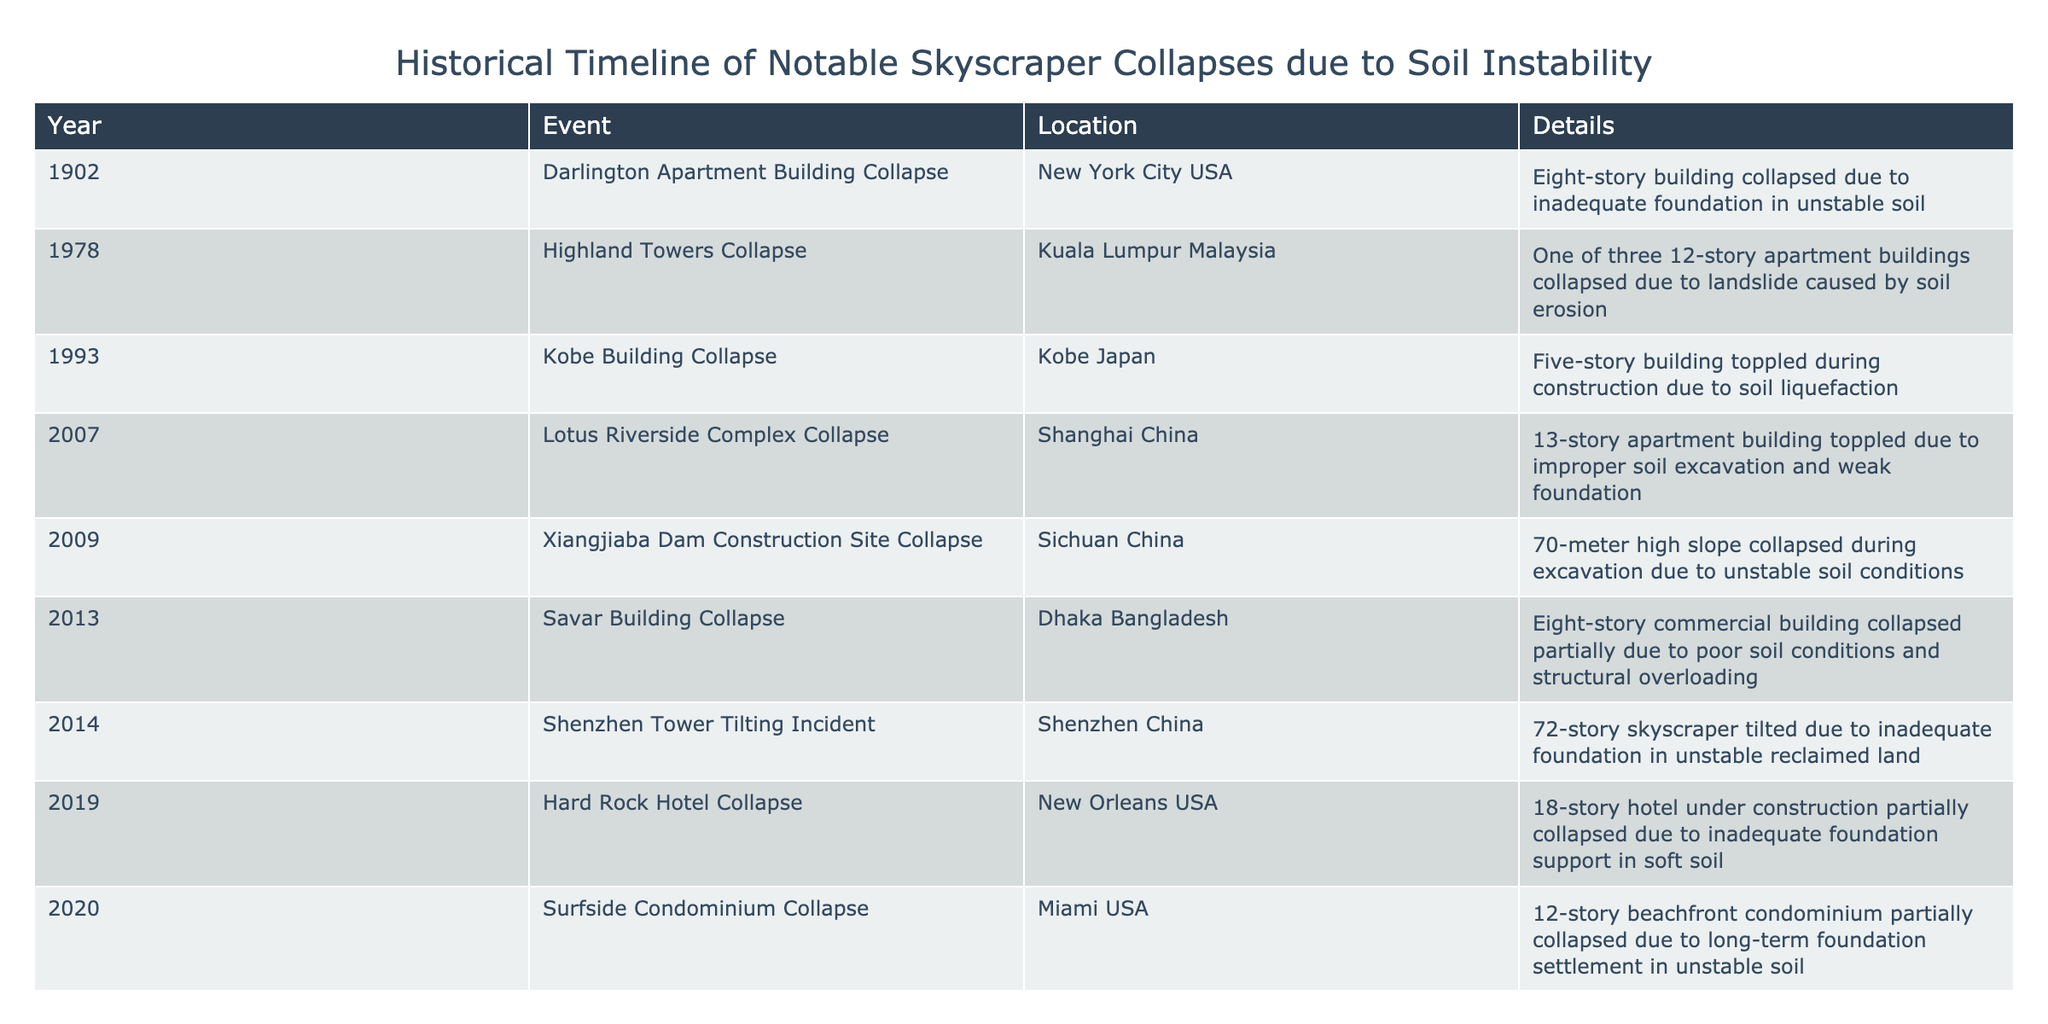What year did the Darlington Apartment Building Collapse occur? The table lists various events along with their years. By locating the "Darlington Apartment Building Collapse" in the "Event" column, we find that it corresponds to the year 1902 in the "Year" column.
Answer: 1902 Which specific collapse was caused by soil liquefaction? Looking at the "Details" column, we see that the "Kobe Building Collapse" in 1993 is the only event that explicitly mentions the term "soil liquefaction." Thus, it refers to this specific incident.
Answer: Kobe Building Collapse How many total collapses occurred in China? We can count the occurrences in the "Location" column that mention "China." The events listed are for the Lotus Riverside Complex Collapse (2007), Xiangjiaba Dam Construction Site Collapse (2009), Shenzhen Tower Tilting Incident (2014), and Changsha Building Collapse (2022). That gives us a total of four collapses in China.
Answer: 4 Is it true that all events listed occurred after the year 2000? To verify this statement, we check the "Year" column for all listed events. The earliest, the Darlington Apartment Building Collapse, occurred in 1902. Therefore, not all events occurred after the year 2000, making the statement false.
Answer: No What is the recurrence of incidents specifically mentioning inadequate foundation? By scanning the "Details" column, we identify the following events that mention "inadequate foundation": Darlington Apartment Building Collapse (1902), Shenzhen Tower Tilting Incident (2014), and Hard Rock Hotel Collapse (2019). This makes a total of three incidents related to inadequate foundation.
Answer: 3 Which event occurred in 2013, and what was its cause? We refer to the "Year" column and find that 2013 corresponds to the "Savar Building Collapse." According to the "Details," it collapsed partially due to poor soil conditions and structural overloading. Therefore, that is the event and the cause in this year.
Answer: Savar Building Collapse due to poor soil conditions and structural overloading What percentage of the collapses mentioned occurred in the 21st century? First, we identify the total number of collapses listed, which is 10. Next, we check how many occurred in the 21st century. The events in the 21st century include Lotus Riverside Complex Collapse (2007), Xiangjiaba Dam Construction Site Collapse (2009), Shenzhen Tower Tilting Incident (2014), Hard Rock Hotel Collapse (2019), Surfside Condominium Collapse (2020), and Changsha Building Collapse (2022). This gives us 6 events. The percentage is calculated as (6/10) * 100 = 60%.
Answer: 60% Was there a collapse that featured a landslide as a contributing factor? Reviewing the "Details" column, we find the "Highland Towers Collapse" in 1978, which states it collapsed due to a landslide caused by soil erosion. Therefore, there was indeed such a collapse.
Answer: Yes How many more collapses occurred in the USA compared to Malaysia? By checking the locations, the collapses in the USA include the Darlington Apartment Building Collapse (1902), Hard Rock Hotel Collapse (2019), and Surfside Condominium Collapse (2020), totaling 3 incidents. In Malaysia, we find the Highland Towers Collapse (1978), giving us only 1 incident. The difference is 3 - 1 = 2.
Answer: 2 